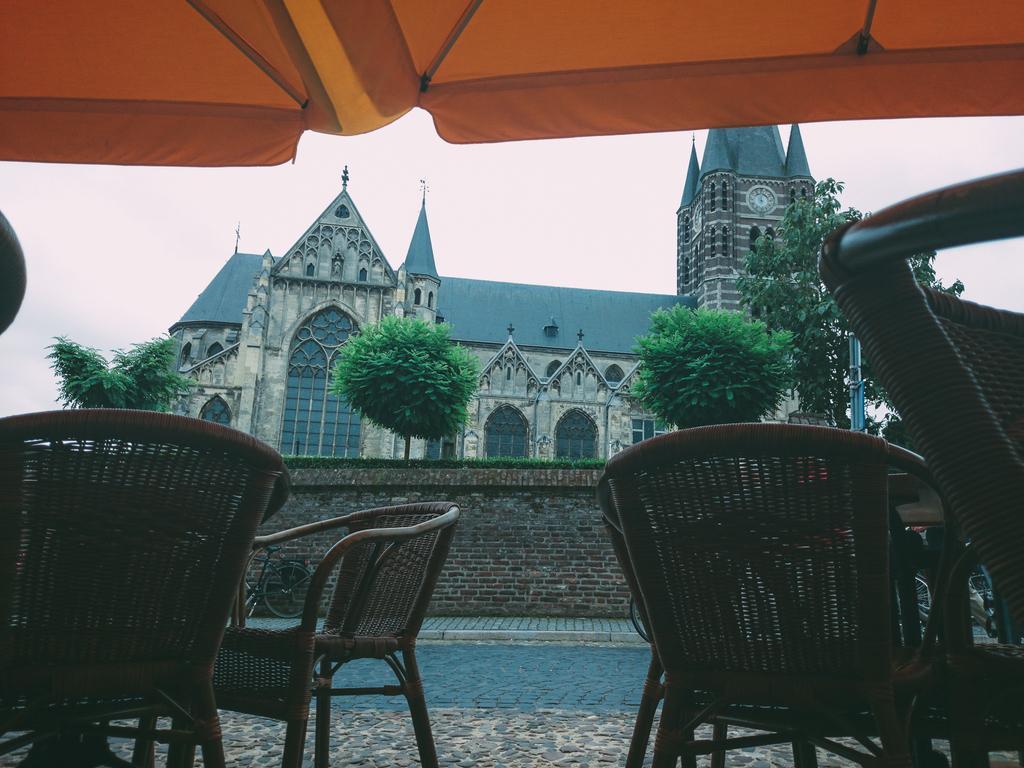Can you describe this image briefly? This is an outside view. At the bottom there are few chairs under a tent. In the background there is a road. Beside the road there is a wall. In the background there is a building, few trees and also I can see the sky. 